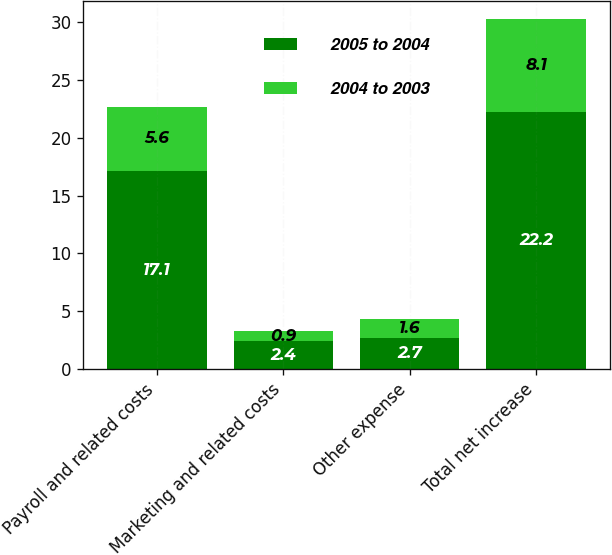Convert chart to OTSL. <chart><loc_0><loc_0><loc_500><loc_500><stacked_bar_chart><ecel><fcel>Payroll and related costs<fcel>Marketing and related costs<fcel>Other expense<fcel>Total net increase<nl><fcel>2005 to 2004<fcel>17.1<fcel>2.4<fcel>2.7<fcel>22.2<nl><fcel>2004 to 2003<fcel>5.6<fcel>0.9<fcel>1.6<fcel>8.1<nl></chart> 